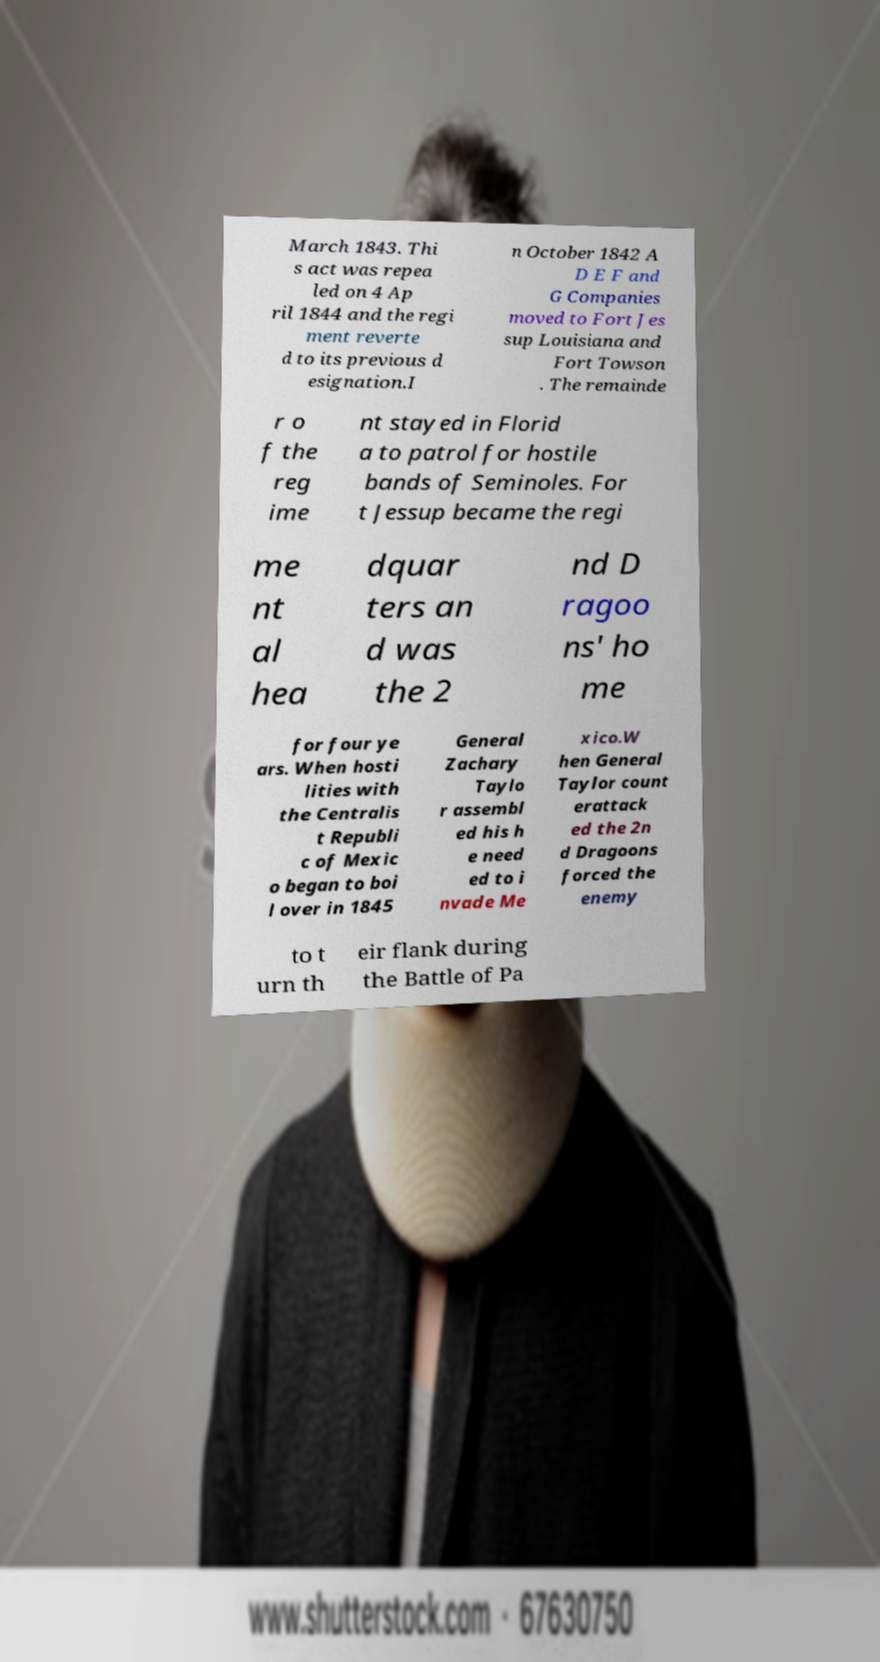I need the written content from this picture converted into text. Can you do that? March 1843. Thi s act was repea led on 4 Ap ril 1844 and the regi ment reverte d to its previous d esignation.I n October 1842 A D E F and G Companies moved to Fort Jes sup Louisiana and Fort Towson . The remainde r o f the reg ime nt stayed in Florid a to patrol for hostile bands of Seminoles. For t Jessup became the regi me nt al hea dquar ters an d was the 2 nd D ragoo ns' ho me for four ye ars. When hosti lities with the Centralis t Republi c of Mexic o began to boi l over in 1845 General Zachary Taylo r assembl ed his h e need ed to i nvade Me xico.W hen General Taylor count erattack ed the 2n d Dragoons forced the enemy to t urn th eir flank during the Battle of Pa 